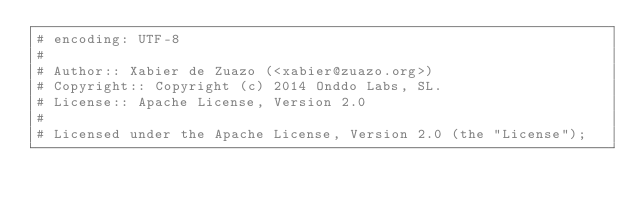<code> <loc_0><loc_0><loc_500><loc_500><_Ruby_># encoding: UTF-8
#
# Author:: Xabier de Zuazo (<xabier@zuazo.org>)
# Copyright:: Copyright (c) 2014 Onddo Labs, SL.
# License:: Apache License, Version 2.0
#
# Licensed under the Apache License, Version 2.0 (the "License");</code> 